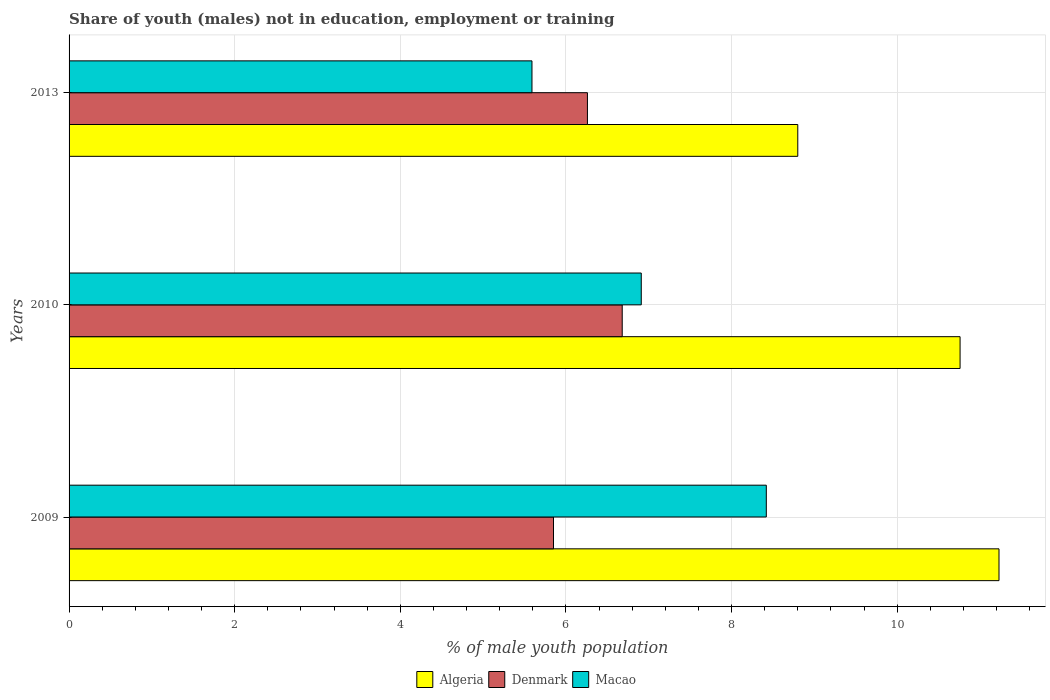How many bars are there on the 2nd tick from the bottom?
Keep it short and to the point. 3. What is the label of the 2nd group of bars from the top?
Make the answer very short. 2010. What is the percentage of unemployed males population in in Denmark in 2013?
Provide a short and direct response. 6.26. Across all years, what is the maximum percentage of unemployed males population in in Denmark?
Your response must be concise. 6.68. Across all years, what is the minimum percentage of unemployed males population in in Denmark?
Make the answer very short. 5.85. In which year was the percentage of unemployed males population in in Algeria maximum?
Your answer should be compact. 2009. In which year was the percentage of unemployed males population in in Denmark minimum?
Ensure brevity in your answer.  2009. What is the total percentage of unemployed males population in in Macao in the graph?
Give a very brief answer. 20.92. What is the difference between the percentage of unemployed males population in in Denmark in 2009 and that in 2013?
Your answer should be very brief. -0.41. What is the difference between the percentage of unemployed males population in in Algeria in 2009 and the percentage of unemployed males population in in Denmark in 2013?
Provide a succinct answer. 4.97. What is the average percentage of unemployed males population in in Denmark per year?
Offer a terse response. 6.26. In the year 2009, what is the difference between the percentage of unemployed males population in in Macao and percentage of unemployed males population in in Denmark?
Give a very brief answer. 2.57. What is the ratio of the percentage of unemployed males population in in Denmark in 2009 to that in 2013?
Your response must be concise. 0.93. Is the difference between the percentage of unemployed males population in in Macao in 2009 and 2010 greater than the difference between the percentage of unemployed males population in in Denmark in 2009 and 2010?
Offer a very short reply. Yes. What is the difference between the highest and the second highest percentage of unemployed males population in in Macao?
Provide a succinct answer. 1.51. What is the difference between the highest and the lowest percentage of unemployed males population in in Denmark?
Your answer should be very brief. 0.83. Is the sum of the percentage of unemployed males population in in Algeria in 2010 and 2013 greater than the maximum percentage of unemployed males population in in Denmark across all years?
Provide a short and direct response. Yes. What does the 1st bar from the top in 2010 represents?
Provide a short and direct response. Macao. How many bars are there?
Make the answer very short. 9. What is the difference between two consecutive major ticks on the X-axis?
Offer a very short reply. 2. Where does the legend appear in the graph?
Give a very brief answer. Bottom center. What is the title of the graph?
Provide a short and direct response. Share of youth (males) not in education, employment or training. What is the label or title of the X-axis?
Your answer should be very brief. % of male youth population. What is the label or title of the Y-axis?
Your response must be concise. Years. What is the % of male youth population in Algeria in 2009?
Make the answer very short. 11.23. What is the % of male youth population in Denmark in 2009?
Keep it short and to the point. 5.85. What is the % of male youth population in Macao in 2009?
Your answer should be very brief. 8.42. What is the % of male youth population in Algeria in 2010?
Your answer should be compact. 10.76. What is the % of male youth population of Denmark in 2010?
Offer a terse response. 6.68. What is the % of male youth population of Macao in 2010?
Your answer should be compact. 6.91. What is the % of male youth population in Algeria in 2013?
Your response must be concise. 8.8. What is the % of male youth population of Denmark in 2013?
Your answer should be very brief. 6.26. What is the % of male youth population of Macao in 2013?
Offer a terse response. 5.59. Across all years, what is the maximum % of male youth population of Algeria?
Provide a succinct answer. 11.23. Across all years, what is the maximum % of male youth population in Denmark?
Your answer should be compact. 6.68. Across all years, what is the maximum % of male youth population in Macao?
Provide a short and direct response. 8.42. Across all years, what is the minimum % of male youth population in Algeria?
Give a very brief answer. 8.8. Across all years, what is the minimum % of male youth population in Denmark?
Ensure brevity in your answer.  5.85. Across all years, what is the minimum % of male youth population in Macao?
Keep it short and to the point. 5.59. What is the total % of male youth population of Algeria in the graph?
Make the answer very short. 30.79. What is the total % of male youth population in Denmark in the graph?
Offer a terse response. 18.79. What is the total % of male youth population of Macao in the graph?
Keep it short and to the point. 20.92. What is the difference between the % of male youth population of Algeria in 2009 and that in 2010?
Your answer should be compact. 0.47. What is the difference between the % of male youth population of Denmark in 2009 and that in 2010?
Offer a terse response. -0.83. What is the difference between the % of male youth population of Macao in 2009 and that in 2010?
Keep it short and to the point. 1.51. What is the difference between the % of male youth population of Algeria in 2009 and that in 2013?
Give a very brief answer. 2.43. What is the difference between the % of male youth population in Denmark in 2009 and that in 2013?
Your response must be concise. -0.41. What is the difference between the % of male youth population in Macao in 2009 and that in 2013?
Your response must be concise. 2.83. What is the difference between the % of male youth population in Algeria in 2010 and that in 2013?
Give a very brief answer. 1.96. What is the difference between the % of male youth population in Denmark in 2010 and that in 2013?
Provide a succinct answer. 0.42. What is the difference between the % of male youth population of Macao in 2010 and that in 2013?
Make the answer very short. 1.32. What is the difference between the % of male youth population in Algeria in 2009 and the % of male youth population in Denmark in 2010?
Make the answer very short. 4.55. What is the difference between the % of male youth population in Algeria in 2009 and the % of male youth population in Macao in 2010?
Give a very brief answer. 4.32. What is the difference between the % of male youth population in Denmark in 2009 and the % of male youth population in Macao in 2010?
Make the answer very short. -1.06. What is the difference between the % of male youth population in Algeria in 2009 and the % of male youth population in Denmark in 2013?
Your answer should be very brief. 4.97. What is the difference between the % of male youth population of Algeria in 2009 and the % of male youth population of Macao in 2013?
Offer a very short reply. 5.64. What is the difference between the % of male youth population of Denmark in 2009 and the % of male youth population of Macao in 2013?
Your answer should be compact. 0.26. What is the difference between the % of male youth population in Algeria in 2010 and the % of male youth population in Denmark in 2013?
Your answer should be very brief. 4.5. What is the difference between the % of male youth population of Algeria in 2010 and the % of male youth population of Macao in 2013?
Offer a very short reply. 5.17. What is the difference between the % of male youth population of Denmark in 2010 and the % of male youth population of Macao in 2013?
Keep it short and to the point. 1.09. What is the average % of male youth population of Algeria per year?
Offer a very short reply. 10.26. What is the average % of male youth population of Denmark per year?
Provide a short and direct response. 6.26. What is the average % of male youth population of Macao per year?
Keep it short and to the point. 6.97. In the year 2009, what is the difference between the % of male youth population in Algeria and % of male youth population in Denmark?
Make the answer very short. 5.38. In the year 2009, what is the difference between the % of male youth population in Algeria and % of male youth population in Macao?
Provide a short and direct response. 2.81. In the year 2009, what is the difference between the % of male youth population of Denmark and % of male youth population of Macao?
Provide a succinct answer. -2.57. In the year 2010, what is the difference between the % of male youth population in Algeria and % of male youth population in Denmark?
Offer a terse response. 4.08. In the year 2010, what is the difference between the % of male youth population of Algeria and % of male youth population of Macao?
Your response must be concise. 3.85. In the year 2010, what is the difference between the % of male youth population in Denmark and % of male youth population in Macao?
Ensure brevity in your answer.  -0.23. In the year 2013, what is the difference between the % of male youth population in Algeria and % of male youth population in Denmark?
Offer a terse response. 2.54. In the year 2013, what is the difference between the % of male youth population of Algeria and % of male youth population of Macao?
Your answer should be very brief. 3.21. In the year 2013, what is the difference between the % of male youth population of Denmark and % of male youth population of Macao?
Offer a very short reply. 0.67. What is the ratio of the % of male youth population in Algeria in 2009 to that in 2010?
Make the answer very short. 1.04. What is the ratio of the % of male youth population in Denmark in 2009 to that in 2010?
Ensure brevity in your answer.  0.88. What is the ratio of the % of male youth population in Macao in 2009 to that in 2010?
Your answer should be compact. 1.22. What is the ratio of the % of male youth population in Algeria in 2009 to that in 2013?
Your answer should be compact. 1.28. What is the ratio of the % of male youth population of Denmark in 2009 to that in 2013?
Give a very brief answer. 0.93. What is the ratio of the % of male youth population in Macao in 2009 to that in 2013?
Offer a terse response. 1.51. What is the ratio of the % of male youth population of Algeria in 2010 to that in 2013?
Your answer should be very brief. 1.22. What is the ratio of the % of male youth population of Denmark in 2010 to that in 2013?
Ensure brevity in your answer.  1.07. What is the ratio of the % of male youth population in Macao in 2010 to that in 2013?
Offer a very short reply. 1.24. What is the difference between the highest and the second highest % of male youth population in Algeria?
Offer a terse response. 0.47. What is the difference between the highest and the second highest % of male youth population of Denmark?
Provide a short and direct response. 0.42. What is the difference between the highest and the second highest % of male youth population of Macao?
Keep it short and to the point. 1.51. What is the difference between the highest and the lowest % of male youth population of Algeria?
Ensure brevity in your answer.  2.43. What is the difference between the highest and the lowest % of male youth population in Denmark?
Offer a very short reply. 0.83. What is the difference between the highest and the lowest % of male youth population in Macao?
Your answer should be very brief. 2.83. 